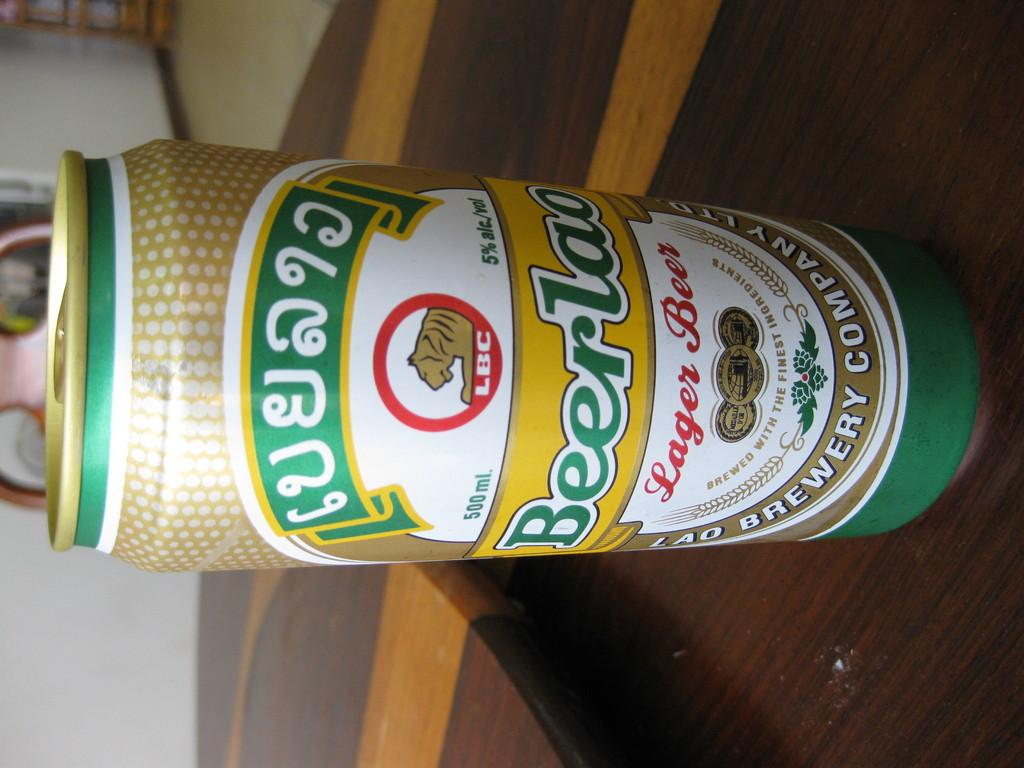<image>
Render a clear and concise summary of the photo. A multi colored can of BeerLao Lager Beer sitting on a table. 